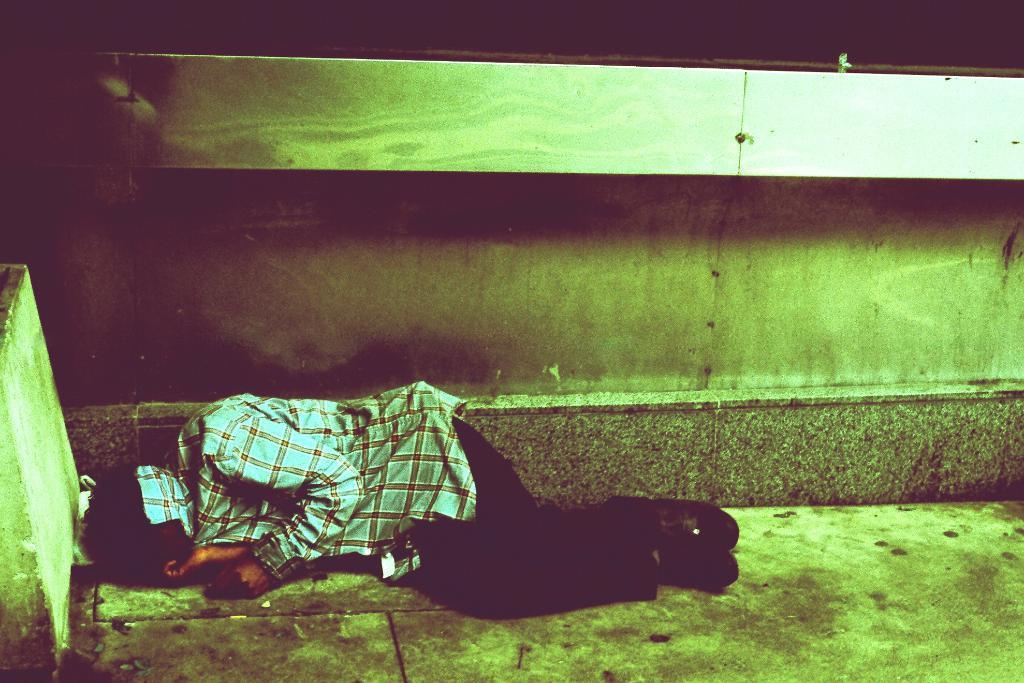Could you give a brief overview of what you see in this image? At the bottom of the image there is a person sleeping on the floor. In the background of the image there is wall. To the left side of the image there is a pillar. 